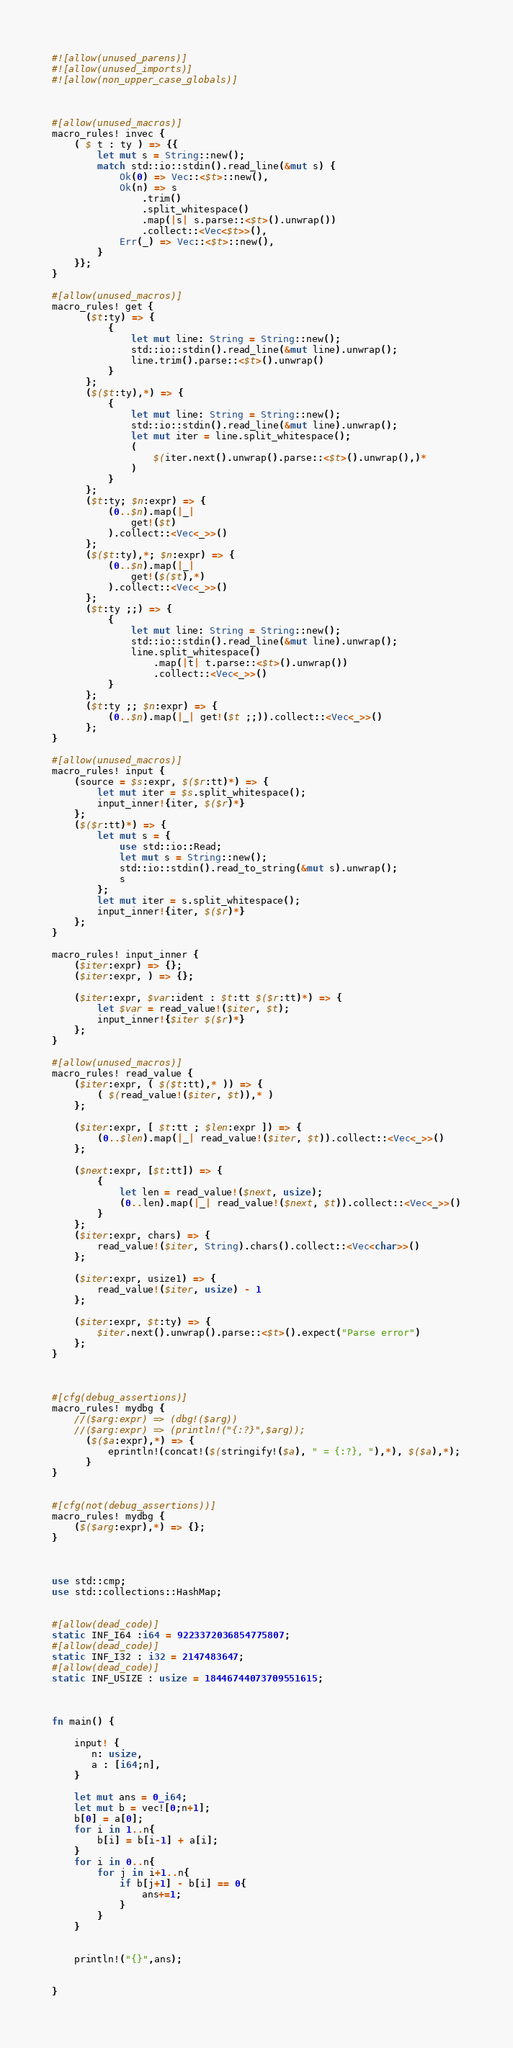<code> <loc_0><loc_0><loc_500><loc_500><_Rust_>#![allow(unused_parens)]
#![allow(unused_imports)]
#![allow(non_upper_case_globals)]



#[allow(unused_macros)]
macro_rules! invec {
    ( $ t : ty ) => {{
        let mut s = String::new();
        match std::io::stdin().read_line(&mut s) {
            Ok(0) => Vec::<$t>::new(),
            Ok(n) => s
                .trim()
                .split_whitespace()
                .map(|s| s.parse::<$t>().unwrap())
                .collect::<Vec<$t>>(),
            Err(_) => Vec::<$t>::new(),
        }
    }};
}

#[allow(unused_macros)]
macro_rules! get {
      ($t:ty) => {
          {
              let mut line: String = String::new();
              std::io::stdin().read_line(&mut line).unwrap();
              line.trim().parse::<$t>().unwrap()
          }
      };
      ($($t:ty),*) => {
          {
              let mut line: String = String::new();
              std::io::stdin().read_line(&mut line).unwrap();
              let mut iter = line.split_whitespace();
              (
                  $(iter.next().unwrap().parse::<$t>().unwrap(),)*
              )
          }
      };
      ($t:ty; $n:expr) => {
          (0..$n).map(|_|
              get!($t)
          ).collect::<Vec<_>>()
      };
      ($($t:ty),*; $n:expr) => {
          (0..$n).map(|_|
              get!($($t),*)
          ).collect::<Vec<_>>()
      };
      ($t:ty ;;) => {
          {
              let mut line: String = String::new();
              std::io::stdin().read_line(&mut line).unwrap();
              line.split_whitespace()
                  .map(|t| t.parse::<$t>().unwrap())
                  .collect::<Vec<_>>()
          }
      };
      ($t:ty ;; $n:expr) => {
          (0..$n).map(|_| get!($t ;;)).collect::<Vec<_>>()
      };
}

#[allow(unused_macros)]
macro_rules! input {
    (source = $s:expr, $($r:tt)*) => {
        let mut iter = $s.split_whitespace();
        input_inner!{iter, $($r)*}
    };
    ($($r:tt)*) => {
        let mut s = {
            use std::io::Read;
            let mut s = String::new();
            std::io::stdin().read_to_string(&mut s).unwrap();
            s
        };
        let mut iter = s.split_whitespace();
        input_inner!{iter, $($r)*}
    };
}

macro_rules! input_inner {
    ($iter:expr) => {};
    ($iter:expr, ) => {};

    ($iter:expr, $var:ident : $t:tt $($r:tt)*) => {
        let $var = read_value!($iter, $t);
        input_inner!{$iter $($r)*}
    };
}

#[allow(unused_macros)]
macro_rules! read_value {
    ($iter:expr, ( $($t:tt),* )) => {
        ( $(read_value!($iter, $t)),* )
    };

    ($iter:expr, [ $t:tt ; $len:expr ]) => {
        (0..$len).map(|_| read_value!($iter, $t)).collect::<Vec<_>>()
    };

    ($next:expr, [$t:tt]) => {
        {
            let len = read_value!($next, usize);
            (0..len).map(|_| read_value!($next, $t)).collect::<Vec<_>>()
        }
    };
    ($iter:expr, chars) => {
        read_value!($iter, String).chars().collect::<Vec<char>>()
    };

    ($iter:expr, usize1) => {
        read_value!($iter, usize) - 1
    };

    ($iter:expr, $t:ty) => {
        $iter.next().unwrap().parse::<$t>().expect("Parse error")
    };
}


 
#[cfg(debug_assertions)]
macro_rules! mydbg {
    //($arg:expr) => (dbg!($arg))
    //($arg:expr) => (println!("{:?}",$arg));
      ($($a:expr),*) => {
          eprintln!(concat!($(stringify!($a), " = {:?}, "),*), $($a),*);
      }
}
 
 
#[cfg(not(debug_assertions))]
macro_rules! mydbg {
    ($($arg:expr),*) => {};
}



use std::cmp;
use std::collections::HashMap;


#[allow(dead_code)]
static INF_I64 :i64 = 9223372036854775807;
#[allow(dead_code)]
static INF_I32 : i32 = 2147483647;
#[allow(dead_code)]
static INF_USIZE : usize = 18446744073709551615;



fn main() {

    input! { 
       n: usize,
       a : [i64;n],
    }

    let mut ans = 0_i64;
    let mut b = vec![0;n+1];
    b[0] = a[0];
    for i in 1..n{
        b[i] = b[i-1] + a[i];
    }
    for i in 0..n{
        for j in i+1..n{
            if b[j+1] - b[i] == 0{
                ans+=1;
            }
        }
    }
    
    
    println!("{}",ans);


}
</code> 